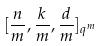<formula> <loc_0><loc_0><loc_500><loc_500>[ \frac { n } { m } , \frac { k } { m } , \frac { d } { m } ] _ { q ^ { m } }</formula> 